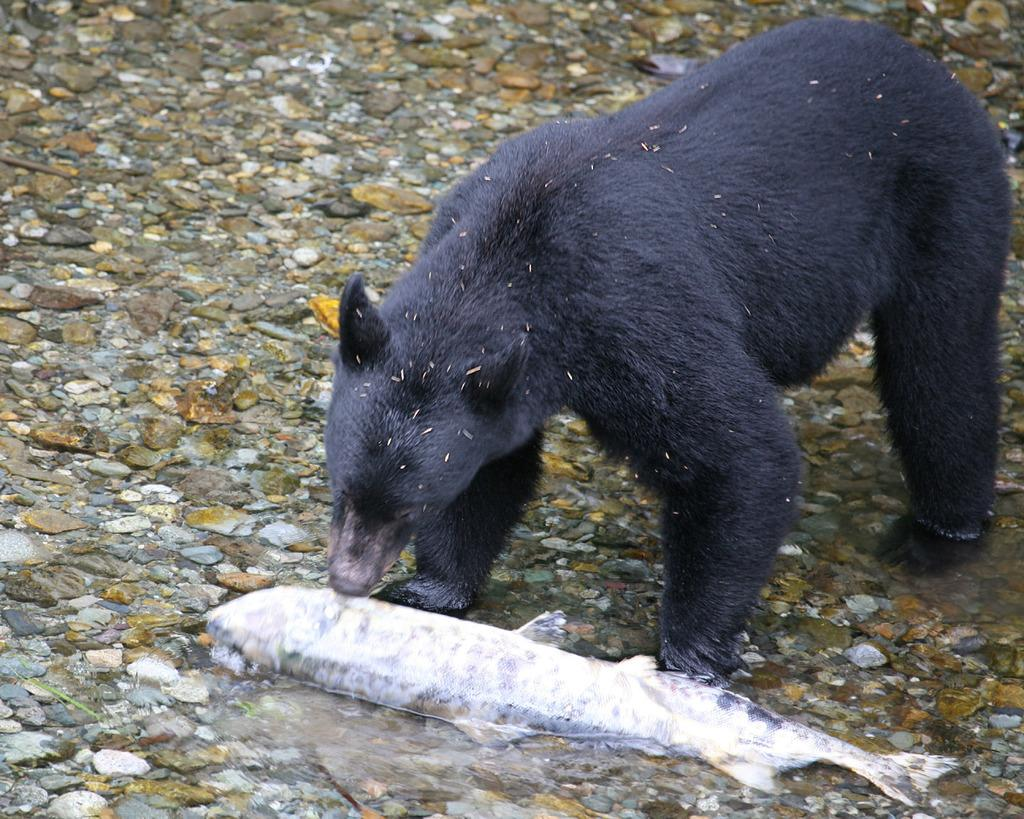What animal is present in the image? There is a bear in the image. What is the bear interacting with in the image? The bear is interacting with fish in the water in the image. What can be seen in the background of the image? There are stones visible in the background of the image. What sound does the bear make while guiding the fish in the image? There is no indication of the bear making any sound or guiding the fish in the image. 